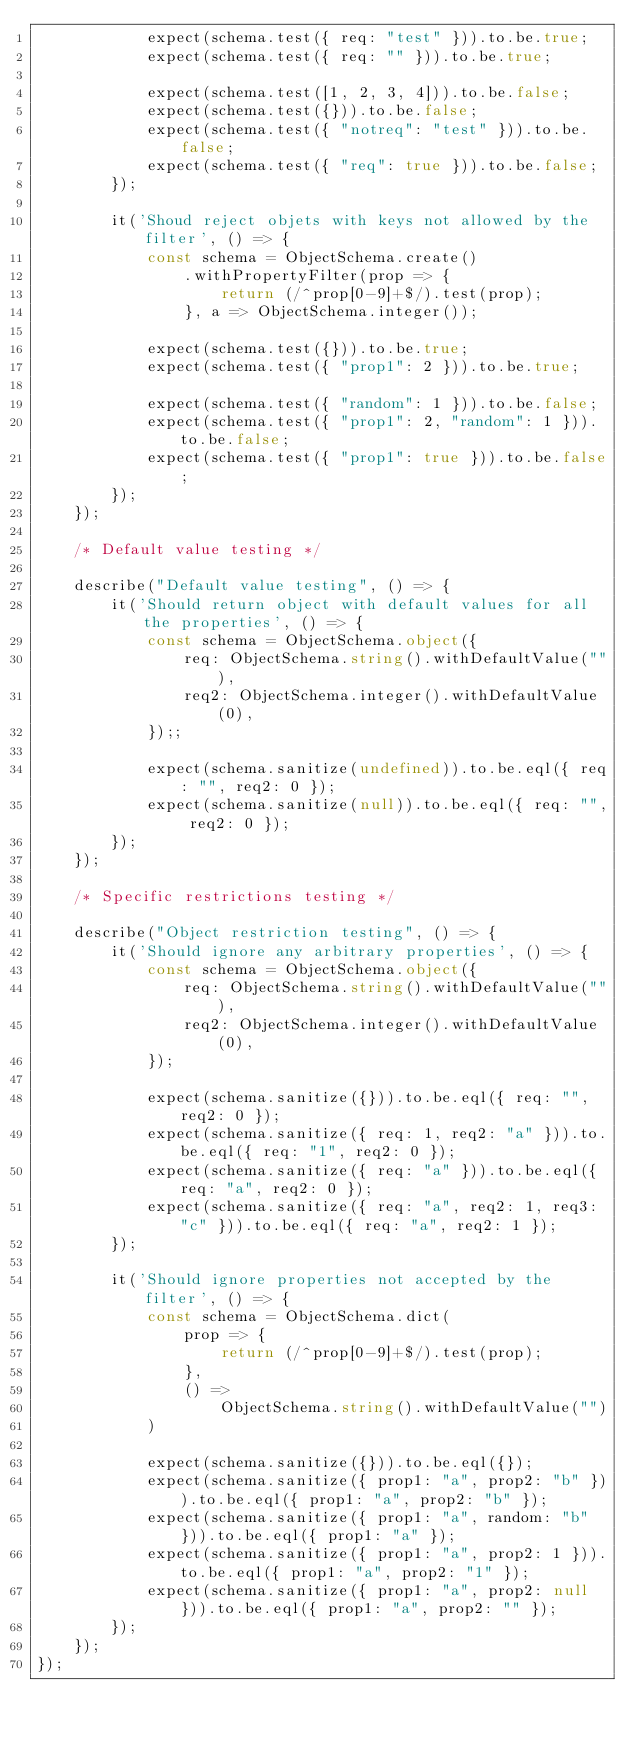<code> <loc_0><loc_0><loc_500><loc_500><_TypeScript_>            expect(schema.test({ req: "test" })).to.be.true;
            expect(schema.test({ req: "" })).to.be.true;

            expect(schema.test([1, 2, 3, 4])).to.be.false;
            expect(schema.test({})).to.be.false;
            expect(schema.test({ "notreq": "test" })).to.be.false;
            expect(schema.test({ "req": true })).to.be.false;
        });

        it('Shoud reject objets with keys not allowed by the filter', () => {
            const schema = ObjectSchema.create()
                .withPropertyFilter(prop => {
                    return (/^prop[0-9]+$/).test(prop);
                }, a => ObjectSchema.integer());

            expect(schema.test({})).to.be.true;
            expect(schema.test({ "prop1": 2 })).to.be.true;

            expect(schema.test({ "random": 1 })).to.be.false;
            expect(schema.test({ "prop1": 2, "random": 1 })).to.be.false;
            expect(schema.test({ "prop1": true })).to.be.false;
        });
    });

    /* Default value testing */

    describe("Default value testing", () => {
        it('Should return object with default values for all the properties', () => {
            const schema = ObjectSchema.object({
                req: ObjectSchema.string().withDefaultValue(""),
                req2: ObjectSchema.integer().withDefaultValue(0),
            });;

            expect(schema.sanitize(undefined)).to.be.eql({ req: "", req2: 0 });
            expect(schema.sanitize(null)).to.be.eql({ req: "", req2: 0 });
        });
    });

    /* Specific restrictions testing */

    describe("Object restriction testing", () => {
        it('Should ignore any arbitrary properties', () => {
            const schema = ObjectSchema.object({
                req: ObjectSchema.string().withDefaultValue(""),
                req2: ObjectSchema.integer().withDefaultValue(0),
            });

            expect(schema.sanitize({})).to.be.eql({ req: "", req2: 0 });
            expect(schema.sanitize({ req: 1, req2: "a" })).to.be.eql({ req: "1", req2: 0 });
            expect(schema.sanitize({ req: "a" })).to.be.eql({ req: "a", req2: 0 });
            expect(schema.sanitize({ req: "a", req2: 1, req3: "c" })).to.be.eql({ req: "a", req2: 1 });
        });

        it('Should ignore properties not accepted by the filter', () => {
            const schema = ObjectSchema.dict(
                prop => {
                    return (/^prop[0-9]+$/).test(prop);
                },
                () =>
                    ObjectSchema.string().withDefaultValue("")
            )

            expect(schema.sanitize({})).to.be.eql({});
            expect(schema.sanitize({ prop1: "a", prop2: "b" })).to.be.eql({ prop1: "a", prop2: "b" });
            expect(schema.sanitize({ prop1: "a", random: "b" })).to.be.eql({ prop1: "a" });
            expect(schema.sanitize({ prop1: "a", prop2: 1 })).to.be.eql({ prop1: "a", prop2: "1" });
            expect(schema.sanitize({ prop1: "a", prop2: null })).to.be.eql({ prop1: "a", prop2: "" });
        });
    });
});
</code> 